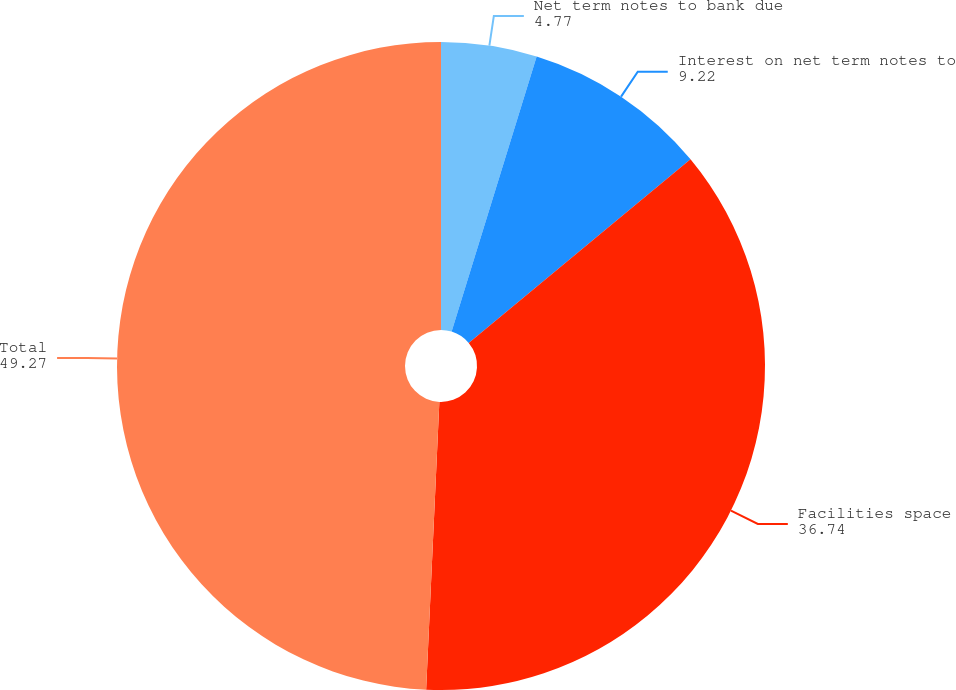Convert chart to OTSL. <chart><loc_0><loc_0><loc_500><loc_500><pie_chart><fcel>Net term notes to bank due<fcel>Interest on net term notes to<fcel>Facilities space<fcel>Total<nl><fcel>4.77%<fcel>9.22%<fcel>36.74%<fcel>49.27%<nl></chart> 